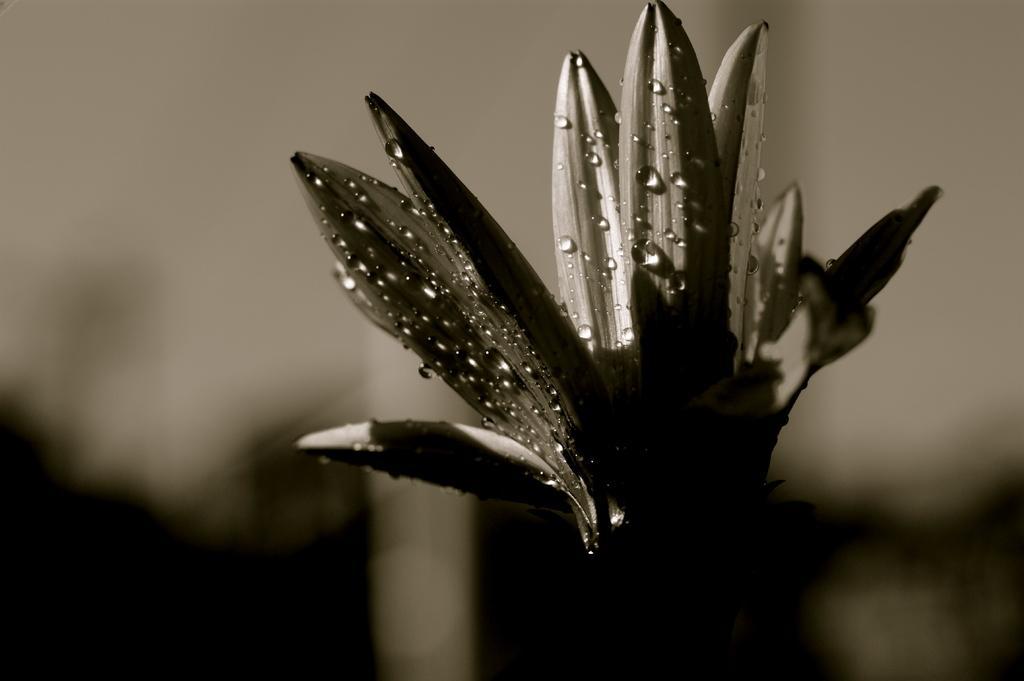Could you give a brief overview of what you see in this image? In this image there are a few water drops on the flower. The background is blurry. 